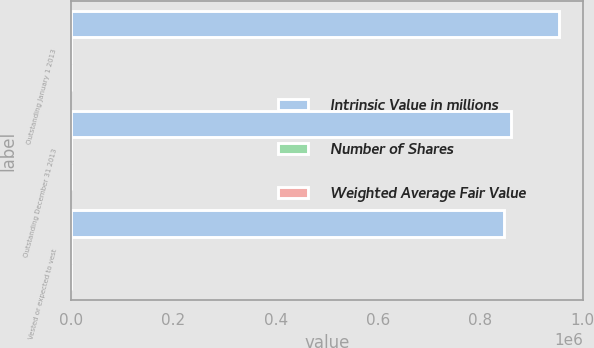Convert chart to OTSL. <chart><loc_0><loc_0><loc_500><loc_500><stacked_bar_chart><ecel><fcel>Outstanding January 1 2013<fcel>Outstanding December 31 2013<fcel>Vested or expected to vest<nl><fcel>Intrinsic Value in millions<fcel>953936<fcel>860657<fcel>846190<nl><fcel>Number of Shares<fcel>67.11<fcel>90.15<fcel>90.02<nl><fcel>Weighted Average Fair Value<fcel>129<fcel>163<fcel>160<nl></chart> 